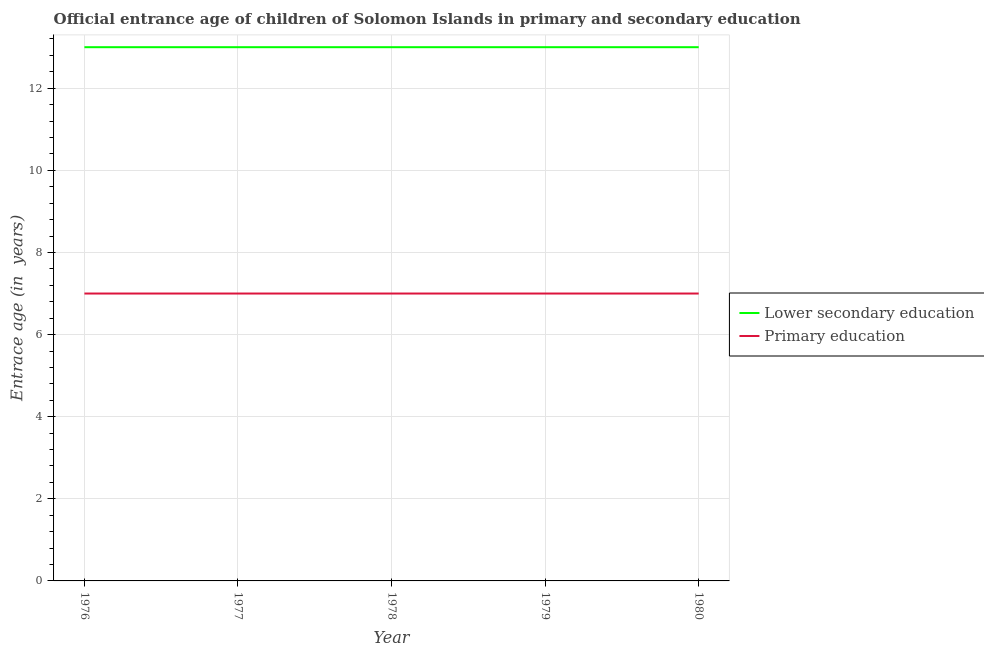Does the line corresponding to entrance age of chiildren in primary education intersect with the line corresponding to entrance age of children in lower secondary education?
Offer a very short reply. No. Is the number of lines equal to the number of legend labels?
Your answer should be very brief. Yes. What is the entrance age of children in lower secondary education in 1976?
Offer a very short reply. 13. Across all years, what is the maximum entrance age of children in lower secondary education?
Give a very brief answer. 13. Across all years, what is the minimum entrance age of chiildren in primary education?
Offer a very short reply. 7. In which year was the entrance age of chiildren in primary education maximum?
Provide a short and direct response. 1976. In which year was the entrance age of children in lower secondary education minimum?
Ensure brevity in your answer.  1976. What is the total entrance age of chiildren in primary education in the graph?
Give a very brief answer. 35. What is the difference between the entrance age of children in lower secondary education in 1976 and that in 1977?
Keep it short and to the point. 0. What is the difference between the entrance age of chiildren in primary education in 1980 and the entrance age of children in lower secondary education in 1977?
Your response must be concise. -6. What is the average entrance age of children in lower secondary education per year?
Your answer should be very brief. 13. In the year 1976, what is the difference between the entrance age of chiildren in primary education and entrance age of children in lower secondary education?
Make the answer very short. -6. What is the ratio of the entrance age of chiildren in primary education in 1976 to that in 1977?
Your response must be concise. 1. Is the entrance age of chiildren in primary education in 1978 less than that in 1980?
Give a very brief answer. No. Is the difference between the entrance age of chiildren in primary education in 1979 and 1980 greater than the difference between the entrance age of children in lower secondary education in 1979 and 1980?
Your response must be concise. No. In how many years, is the entrance age of children in lower secondary education greater than the average entrance age of children in lower secondary education taken over all years?
Offer a very short reply. 0. Does the entrance age of children in lower secondary education monotonically increase over the years?
Provide a short and direct response. No. Is the entrance age of chiildren in primary education strictly greater than the entrance age of children in lower secondary education over the years?
Your answer should be compact. No. How many years are there in the graph?
Offer a terse response. 5. What is the difference between two consecutive major ticks on the Y-axis?
Your answer should be very brief. 2. Where does the legend appear in the graph?
Ensure brevity in your answer.  Center right. How many legend labels are there?
Your response must be concise. 2. What is the title of the graph?
Offer a terse response. Official entrance age of children of Solomon Islands in primary and secondary education. Does "Attending school" appear as one of the legend labels in the graph?
Make the answer very short. No. What is the label or title of the X-axis?
Make the answer very short. Year. What is the label or title of the Y-axis?
Give a very brief answer. Entrace age (in  years). What is the Entrace age (in  years) of Lower secondary education in 1977?
Provide a succinct answer. 13. What is the Entrace age (in  years) in Lower secondary education in 1979?
Keep it short and to the point. 13. What is the Entrace age (in  years) in Primary education in 1979?
Your answer should be very brief. 7. Across all years, what is the maximum Entrace age (in  years) of Lower secondary education?
Your answer should be very brief. 13. Across all years, what is the minimum Entrace age (in  years) of Lower secondary education?
Provide a short and direct response. 13. Across all years, what is the minimum Entrace age (in  years) in Primary education?
Provide a succinct answer. 7. What is the difference between the Entrace age (in  years) of Lower secondary education in 1976 and that in 1977?
Give a very brief answer. 0. What is the difference between the Entrace age (in  years) in Lower secondary education in 1976 and that in 1978?
Ensure brevity in your answer.  0. What is the difference between the Entrace age (in  years) in Primary education in 1976 and that in 1978?
Your answer should be very brief. 0. What is the difference between the Entrace age (in  years) of Lower secondary education in 1976 and that in 1979?
Your answer should be compact. 0. What is the difference between the Entrace age (in  years) in Primary education in 1976 and that in 1979?
Offer a terse response. 0. What is the difference between the Entrace age (in  years) in Lower secondary education in 1976 and that in 1980?
Give a very brief answer. 0. What is the difference between the Entrace age (in  years) of Lower secondary education in 1977 and that in 1978?
Ensure brevity in your answer.  0. What is the difference between the Entrace age (in  years) of Lower secondary education in 1977 and that in 1979?
Your answer should be compact. 0. What is the difference between the Entrace age (in  years) in Primary education in 1977 and that in 1979?
Your response must be concise. 0. What is the difference between the Entrace age (in  years) in Lower secondary education in 1977 and that in 1980?
Offer a terse response. 0. What is the difference between the Entrace age (in  years) in Primary education in 1977 and that in 1980?
Your response must be concise. 0. What is the difference between the Entrace age (in  years) of Primary education in 1978 and that in 1979?
Ensure brevity in your answer.  0. What is the difference between the Entrace age (in  years) of Lower secondary education in 1978 and that in 1980?
Keep it short and to the point. 0. What is the difference between the Entrace age (in  years) in Primary education in 1978 and that in 1980?
Give a very brief answer. 0. What is the difference between the Entrace age (in  years) of Lower secondary education in 1979 and that in 1980?
Keep it short and to the point. 0. What is the difference between the Entrace age (in  years) of Primary education in 1979 and that in 1980?
Provide a short and direct response. 0. What is the difference between the Entrace age (in  years) in Lower secondary education in 1977 and the Entrace age (in  years) in Primary education in 1980?
Ensure brevity in your answer.  6. What is the difference between the Entrace age (in  years) of Lower secondary education in 1978 and the Entrace age (in  years) of Primary education in 1979?
Offer a very short reply. 6. What is the difference between the Entrace age (in  years) of Lower secondary education in 1978 and the Entrace age (in  years) of Primary education in 1980?
Ensure brevity in your answer.  6. What is the average Entrace age (in  years) of Primary education per year?
Ensure brevity in your answer.  7. In the year 1976, what is the difference between the Entrace age (in  years) in Lower secondary education and Entrace age (in  years) in Primary education?
Your answer should be very brief. 6. In the year 1978, what is the difference between the Entrace age (in  years) in Lower secondary education and Entrace age (in  years) in Primary education?
Make the answer very short. 6. In the year 1980, what is the difference between the Entrace age (in  years) of Lower secondary education and Entrace age (in  years) of Primary education?
Keep it short and to the point. 6. What is the ratio of the Entrace age (in  years) of Lower secondary education in 1976 to that in 1977?
Your response must be concise. 1. What is the ratio of the Entrace age (in  years) in Primary education in 1976 to that in 1977?
Keep it short and to the point. 1. What is the ratio of the Entrace age (in  years) in Lower secondary education in 1976 to that in 1978?
Make the answer very short. 1. What is the ratio of the Entrace age (in  years) of Primary education in 1976 to that in 1979?
Ensure brevity in your answer.  1. What is the ratio of the Entrace age (in  years) of Lower secondary education in 1976 to that in 1980?
Make the answer very short. 1. What is the ratio of the Entrace age (in  years) of Primary education in 1977 to that in 1978?
Give a very brief answer. 1. What is the ratio of the Entrace age (in  years) in Primary education in 1977 to that in 1979?
Give a very brief answer. 1. What is the ratio of the Entrace age (in  years) in Lower secondary education in 1977 to that in 1980?
Keep it short and to the point. 1. What is the ratio of the Entrace age (in  years) of Lower secondary education in 1978 to that in 1979?
Provide a succinct answer. 1. What is the ratio of the Entrace age (in  years) of Primary education in 1978 to that in 1979?
Provide a succinct answer. 1. What is the ratio of the Entrace age (in  years) in Primary education in 1978 to that in 1980?
Offer a very short reply. 1. What is the ratio of the Entrace age (in  years) in Lower secondary education in 1979 to that in 1980?
Your answer should be very brief. 1. What is the difference between the highest and the lowest Entrace age (in  years) of Lower secondary education?
Offer a very short reply. 0. What is the difference between the highest and the lowest Entrace age (in  years) of Primary education?
Your response must be concise. 0. 